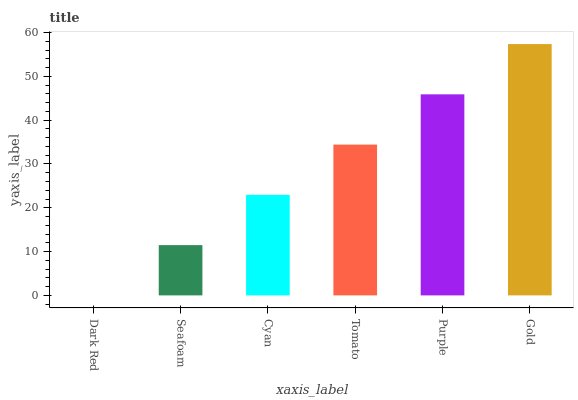Is Seafoam the minimum?
Answer yes or no. No. Is Seafoam the maximum?
Answer yes or no. No. Is Seafoam greater than Dark Red?
Answer yes or no. Yes. Is Dark Red less than Seafoam?
Answer yes or no. Yes. Is Dark Red greater than Seafoam?
Answer yes or no. No. Is Seafoam less than Dark Red?
Answer yes or no. No. Is Tomato the high median?
Answer yes or no. Yes. Is Cyan the low median?
Answer yes or no. Yes. Is Gold the high median?
Answer yes or no. No. Is Gold the low median?
Answer yes or no. No. 